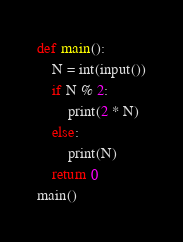Convert code to text. <code><loc_0><loc_0><loc_500><loc_500><_Python_>def main():
	N = int(input())
	if N % 2:
		print(2 * N)
	else:
		print(N)
	return 0
main()</code> 